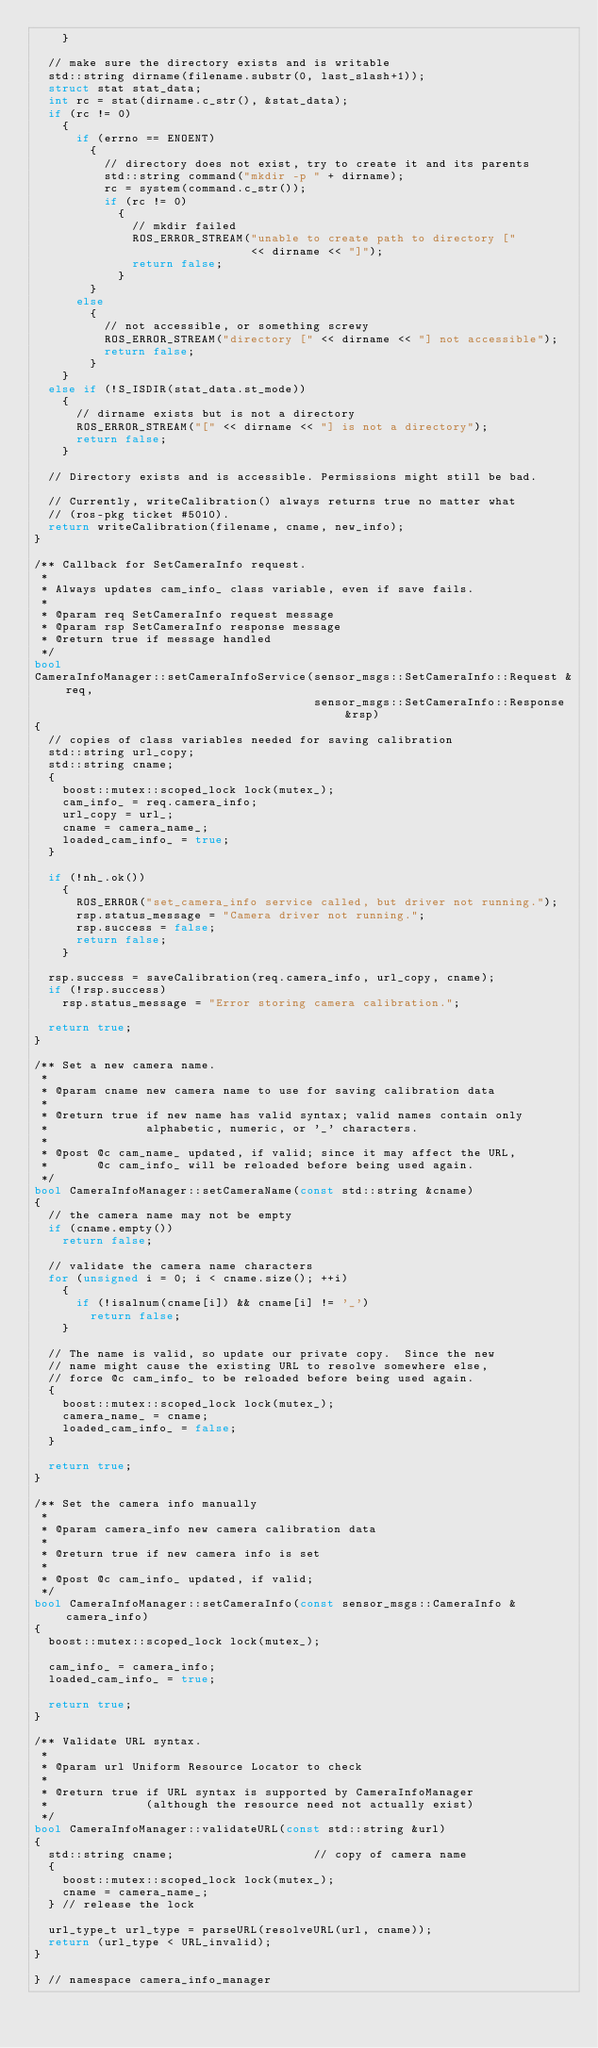Convert code to text. <code><loc_0><loc_0><loc_500><loc_500><_C++_>    }

  // make sure the directory exists and is writable
  std::string dirname(filename.substr(0, last_slash+1));
  struct stat stat_data;
  int rc = stat(dirname.c_str(), &stat_data);
  if (rc != 0)
    {
      if (errno == ENOENT)
        {
          // directory does not exist, try to create it and its parents
          std::string command("mkdir -p " + dirname);
          rc = system(command.c_str());
          if (rc != 0)
            {
              // mkdir failed
              ROS_ERROR_STREAM("unable to create path to directory ["
                               << dirname << "]");
              return false;
            }
        }
      else
        {
          // not accessible, or something screwy
          ROS_ERROR_STREAM("directory [" << dirname << "] not accessible");
          return false;
        }
    }
  else if (!S_ISDIR(stat_data.st_mode))
    {
      // dirname exists but is not a directory
      ROS_ERROR_STREAM("[" << dirname << "] is not a directory");
      return false;
    }

  // Directory exists and is accessible. Permissions might still be bad.

  // Currently, writeCalibration() always returns true no matter what
  // (ros-pkg ticket #5010).
  return writeCalibration(filename, cname, new_info);
}

/** Callback for SetCameraInfo request.
 *
 * Always updates cam_info_ class variable, even if save fails.
 *
 * @param req SetCameraInfo request message
 * @param rsp SetCameraInfo response message
 * @return true if message handled
 */
bool 
CameraInfoManager::setCameraInfoService(sensor_msgs::SetCameraInfo::Request &req,
                                        sensor_msgs::SetCameraInfo::Response &rsp)
{
  // copies of class variables needed for saving calibration
  std::string url_copy;
  std::string cname;
  {
    boost::mutex::scoped_lock lock(mutex_);
    cam_info_ = req.camera_info;
    url_copy = url_;
    cname = camera_name_;
    loaded_cam_info_ = true;
  }

  if (!nh_.ok())
    {
      ROS_ERROR("set_camera_info service called, but driver not running.");
      rsp.status_message = "Camera driver not running.";
      rsp.success = false;
      return false;
    }

  rsp.success = saveCalibration(req.camera_info, url_copy, cname);
  if (!rsp.success)
    rsp.status_message = "Error storing camera calibration.";

  return true;
}

/** Set a new camera name.
 *
 * @param cname new camera name to use for saving calibration data
 *
 * @return true if new name has valid syntax; valid names contain only
 *              alphabetic, numeric, or '_' characters.
 *
 * @post @c cam_name_ updated, if valid; since it may affect the URL,
 *       @c cam_info_ will be reloaded before being used again.
 */
bool CameraInfoManager::setCameraName(const std::string &cname)
{
  // the camera name may not be empty
  if (cname.empty())
    return false;

  // validate the camera name characters
  for (unsigned i = 0; i < cname.size(); ++i)
    {
      if (!isalnum(cname[i]) && cname[i] != '_')
        return false;
    }

  // The name is valid, so update our private copy.  Since the new
  // name might cause the existing URL to resolve somewhere else,
  // force @c cam_info_ to be reloaded before being used again.
  {
    boost::mutex::scoped_lock lock(mutex_);
    camera_name_ = cname;
    loaded_cam_info_ = false;
  }

  return true;
}

/** Set the camera info manually
 *
 * @param camera_info new camera calibration data
 *
 * @return true if new camera info is set
 *
 * @post @c cam_info_ updated, if valid;
 */
bool CameraInfoManager::setCameraInfo(const sensor_msgs::CameraInfo &camera_info)
{
  boost::mutex::scoped_lock lock(mutex_);

  cam_info_ = camera_info;
  loaded_cam_info_ = true;

  return true;
}

/** Validate URL syntax.
 *
 * @param url Uniform Resource Locator to check
 *
 * @return true if URL syntax is supported by CameraInfoManager
 *              (although the resource need not actually exist)
 */
bool CameraInfoManager::validateURL(const std::string &url)
{
  std::string cname;                    // copy of camera name
  {
    boost::mutex::scoped_lock lock(mutex_);
    cname = camera_name_;
  } // release the lock

  url_type_t url_type = parseURL(resolveURL(url, cname));
  return (url_type < URL_invalid);
}

} // namespace camera_info_manager
</code> 